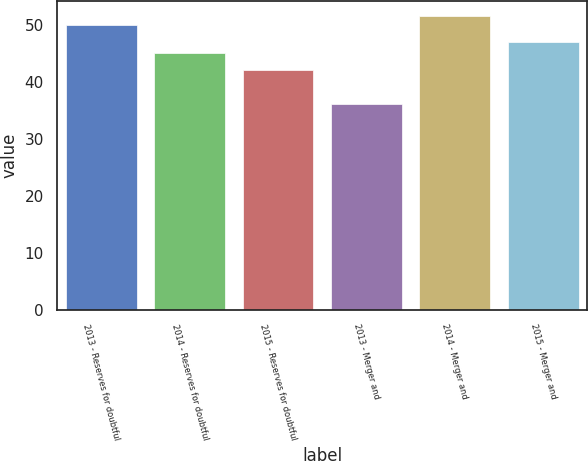<chart> <loc_0><loc_0><loc_500><loc_500><bar_chart><fcel>2013 - Reserves for doubtful<fcel>2014 - Reserves for doubtful<fcel>2015 - Reserves for doubtful<fcel>2013 - Merger and<fcel>2014 - Merger and<fcel>2015 - Merger and<nl><fcel>50<fcel>45<fcel>42<fcel>36<fcel>51.5<fcel>47<nl></chart> 